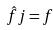<formula> <loc_0><loc_0><loc_500><loc_500>\hat { f } j = f</formula> 